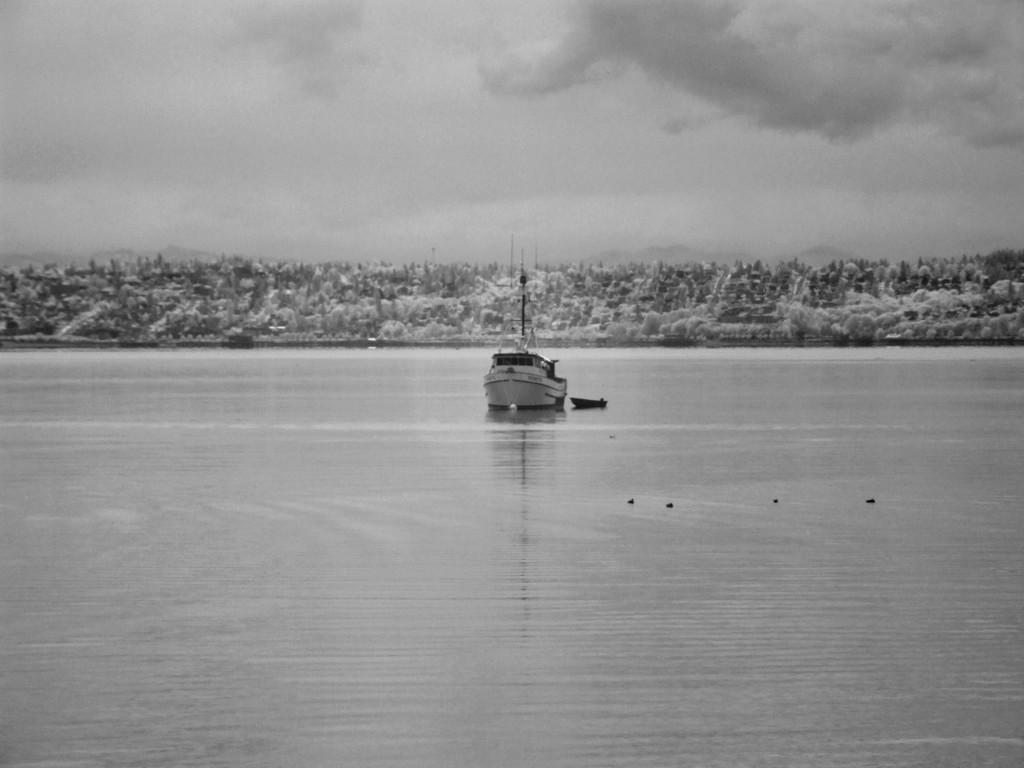How would you summarize this image in a sentence or two? In this image in the front there is water and in the center there is a ship on the water. In the background there are trees and the sky is cloudy. 